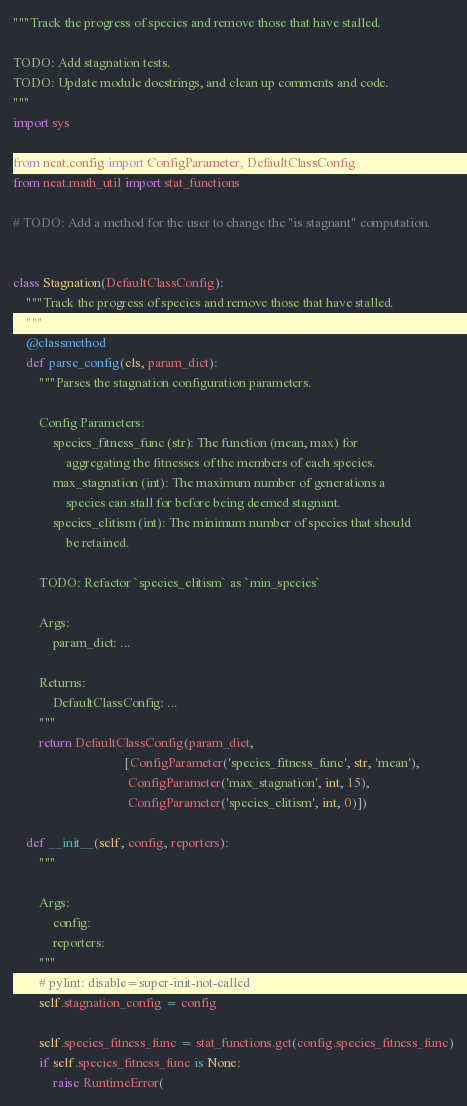<code> <loc_0><loc_0><loc_500><loc_500><_Python_>"""Track the progress of species and remove those that have stalled.

TODO: Add stagnation tests.
TODO: Update module docstrings, and clean up comments and code.
"""
import sys

from neat.config import ConfigParameter, DefaultClassConfig
from neat.math_util import stat_functions

# TODO: Add a method for the user to change the "is stagnant" computation.


class Stagnation(DefaultClassConfig):
    """Track the progress of species and remove those that have stalled.
    """
    @classmethod
    def parse_config(cls, param_dict):
        """Parses the stagnation configuration parameters.

        Config Parameters:
            species_fitness_func (str): The function (mean, max) for
                aggregating the fitnesses of the members of each species.
            max_stagnation (int): The maximum number of generations a
                species can stall for before being deemed stagnant.
            species_elitism (int): The minimum number of species that should
                be retained.

        TODO: Refactor `species_elitism` as `min_species`

        Args:
            param_dict: ...

        Returns:
            DefaultClassConfig: ...
        """
        return DefaultClassConfig(param_dict,
                                  [ConfigParameter('species_fitness_func', str, 'mean'),
                                   ConfigParameter('max_stagnation', int, 15),
                                   ConfigParameter('species_elitism', int, 0)])

    def __init__(self, config, reporters):
        """

        Args:
            config:
            reporters:
        """
        # pylint: disable=super-init-not-called
        self.stagnation_config = config

        self.species_fitness_func = stat_functions.get(config.species_fitness_func)
        if self.species_fitness_func is None:
            raise RuntimeError(</code> 